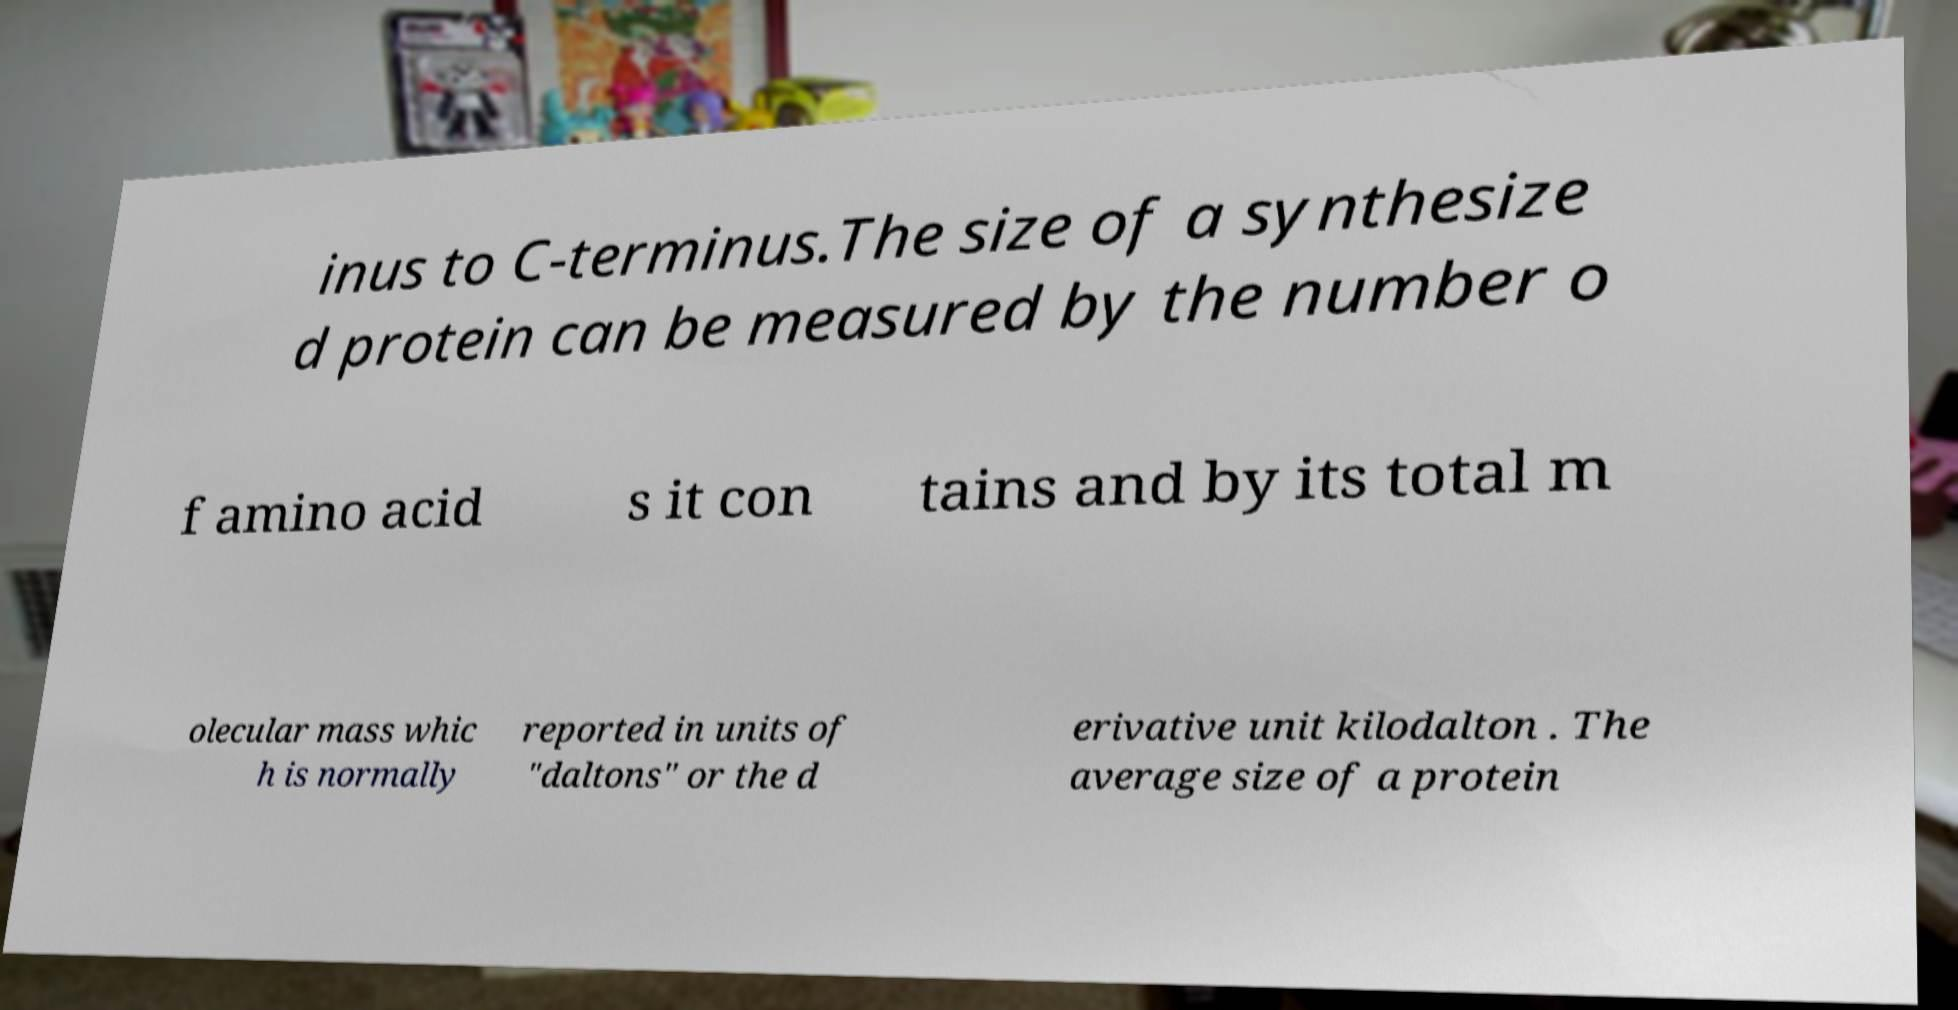I need the written content from this picture converted into text. Can you do that? inus to C-terminus.The size of a synthesize d protein can be measured by the number o f amino acid s it con tains and by its total m olecular mass whic h is normally reported in units of "daltons" or the d erivative unit kilodalton . The average size of a protein 